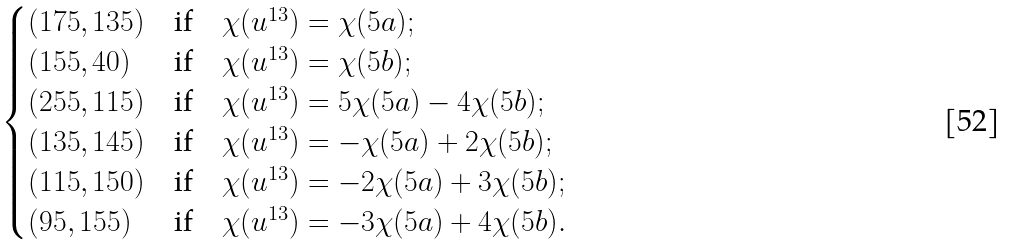Convert formula to latex. <formula><loc_0><loc_0><loc_500><loc_500>\begin{cases} ( 1 7 5 , 1 3 5 ) & \text {if} \quad \chi ( u ^ { 1 3 } ) = \chi ( 5 a ) ; \\ ( 1 5 5 , 4 0 ) & \text {if} \quad \chi ( u ^ { 1 3 } ) = \chi ( 5 b ) ; \\ ( 2 5 5 , 1 1 5 ) & \text {if} \quad \chi ( u ^ { 1 3 } ) = 5 \chi ( 5 a ) - 4 \chi ( 5 b ) ; \\ ( 1 3 5 , 1 4 5 ) & \text {if} \quad \chi ( u ^ { 1 3 } ) = - \chi ( 5 a ) + 2 \chi ( 5 b ) ; \\ ( 1 1 5 , 1 5 0 ) & \text {if} \quad \chi ( u ^ { 1 3 } ) = - 2 \chi ( 5 a ) + 3 \chi ( 5 b ) ; \\ ( 9 5 , 1 5 5 ) & \text {if} \quad \chi ( u ^ { 1 3 } ) = - 3 \chi ( 5 a ) + 4 \chi ( 5 b ) . \\ \end{cases}</formula> 